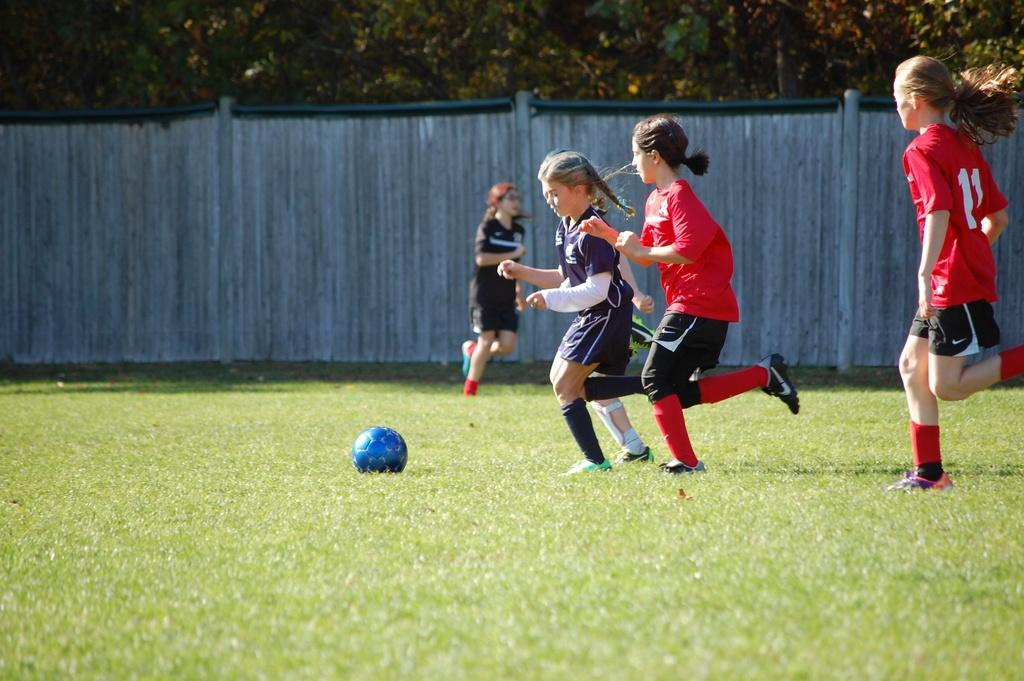How many girls are in the image? There are four girls in the image. What are the girls doing in the image? The girls are playing with a blue color ball. Where is the game taking place? The game is taking place on a grassy land. What can be seen in the background of the image? Trees are present in the background of the image. What type of honey is being used by the girls in the image? There is no honey present in the image; the girls are playing with a blue color ball. How many teeth can be seen in the image? There are no teeth visible in the image; it features four girls playing with a ball. 